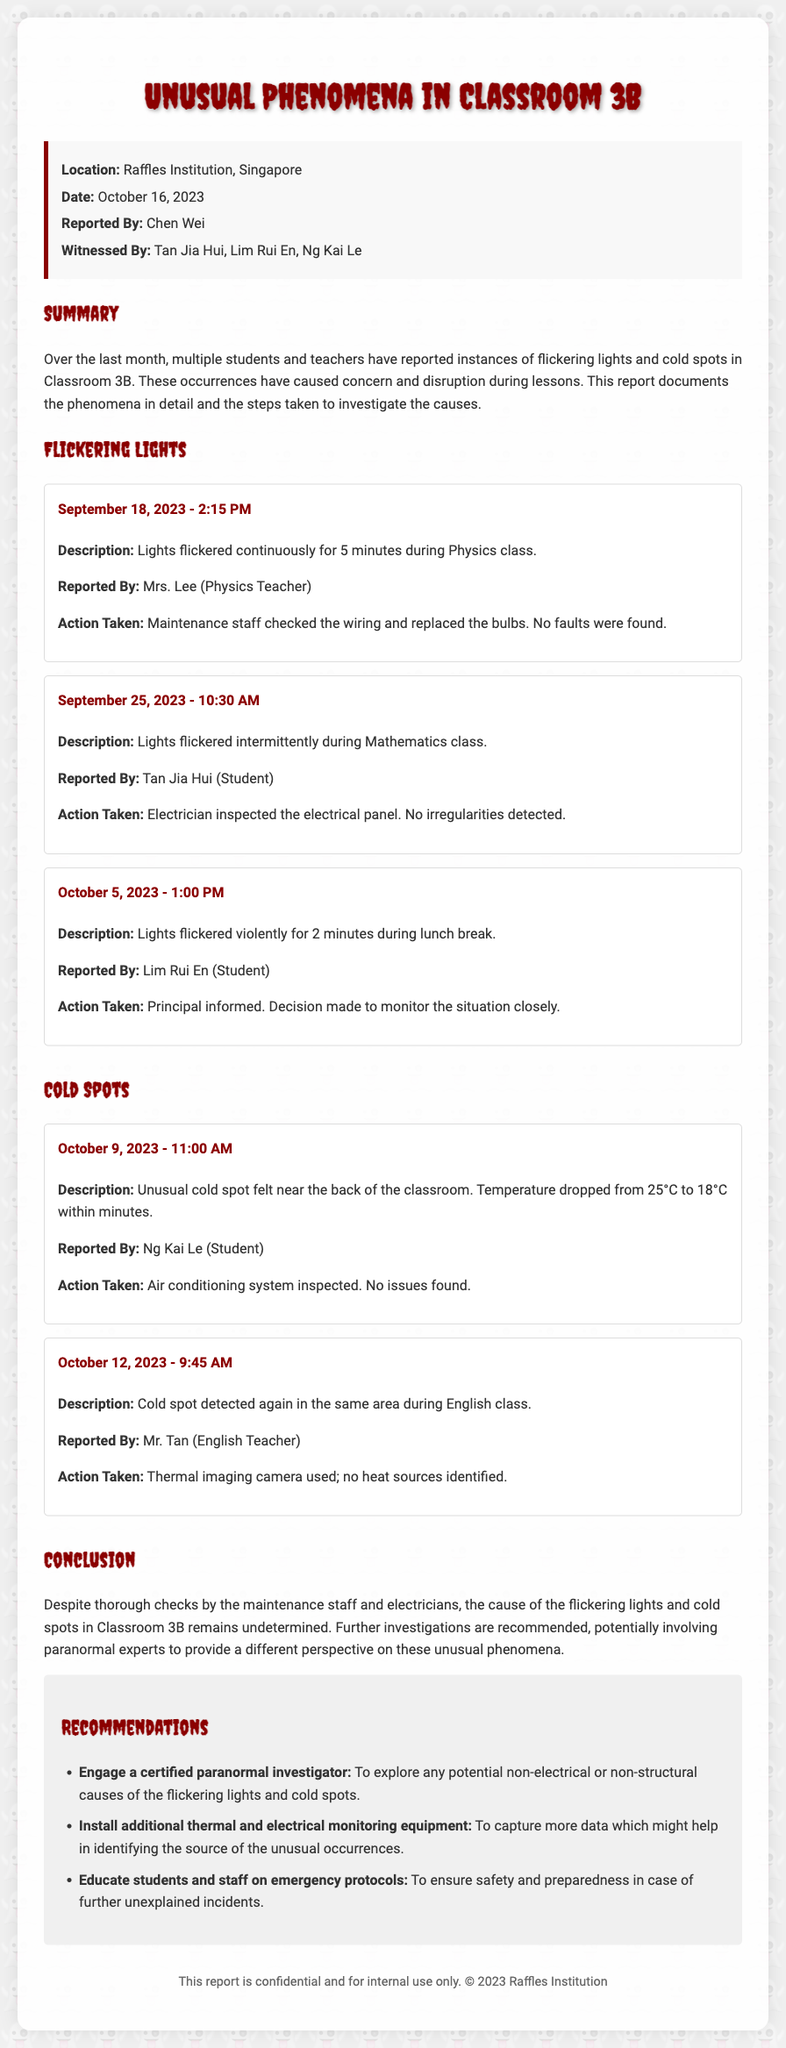what is the date of the incident report? The date listed in the document for the incident report is when the events were reported and documented, which is October 16, 2023.
Answer: October 16, 2023 who reported the incidents? The person who reported the incidents is the individual responsible for compiling the information in the document. The report indicates this person as Chen Wei.
Answer: Chen Wei how many students witnessed the incidents? The document lists the names of those who witnessed the incidents and indicates that a total of three students were present during the observations.
Answer: 3 what was the temperature drop recorded near the cold spot? The document specifies the temperature drop experienced in Classroom 3B, indicating a significant decrease from 25°C to 18°C.
Answer: 7°C when did the flickering lights occur during lunch? The report mentions a specific instance of flickering lights occurring during a time when most students are out of class and identifies the date as October 5, 2023, at 1:00 PM.
Answer: October 5, 2023 what action was taken after the cold spot was detected? The documented actions regarding the cold spots in Classroom 3B include inspection of the air conditioning system and the use of a thermal imaging camera to identify heat sources.
Answer: Inspected the air conditioning system what is one recommendation made in the report? The report outlines several recommendations, including the suggestion to engage a certified paranormal investigator to further investigate the unusual phenomena.
Answer: Engage a certified paranormal investigator who were the witnesses listed in the report? The document provides a list of individuals present during the incidents, specifically naming Tan Jia Hui, Lim Rui En, and Ng Kai Le as the witnesses.
Answer: Tan Jia Hui, Lim Rui En, Ng Kai Le what is the main conclusion of the report? The conclusion summarizes the findings and indicates that despite thorough checks, the source of the flickering lights and cold spots remains uncertain, suggesting further investigations are needed.
Answer: Cause remains undetermined 